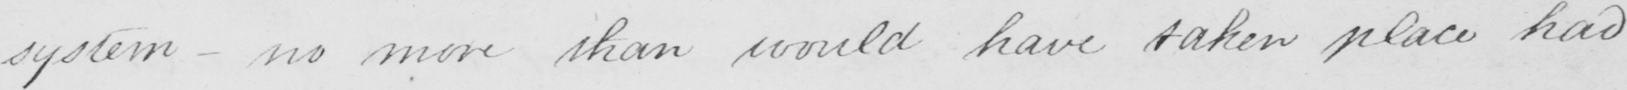What is written in this line of handwriting? system- no more than would have taken place had 